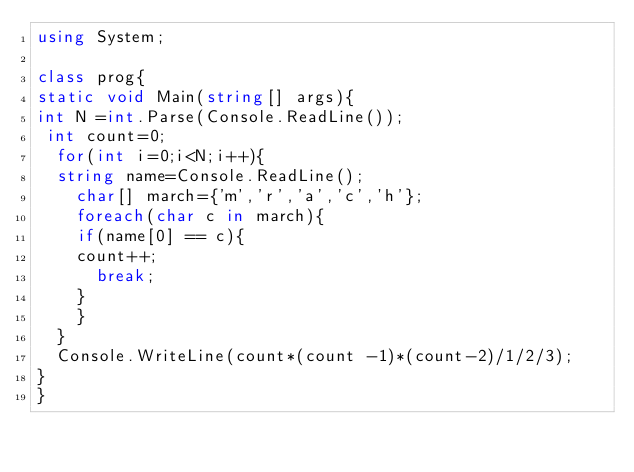Convert code to text. <code><loc_0><loc_0><loc_500><loc_500><_C#_>using System;

class prog{
static void Main(string[] args){
int N =int.Parse(Console.ReadLine());
 int count=0;
  for(int i=0;i<N;i++){
  string name=Console.ReadLine();
    char[] march={'m','r','a','c','h'};
    foreach(char c in march){
    if(name[0] == c){
    count++;
      break;
    }
    }
  }
  Console.WriteLine(count*(count -1)*(count-2)/1/2/3);
}
}</code> 